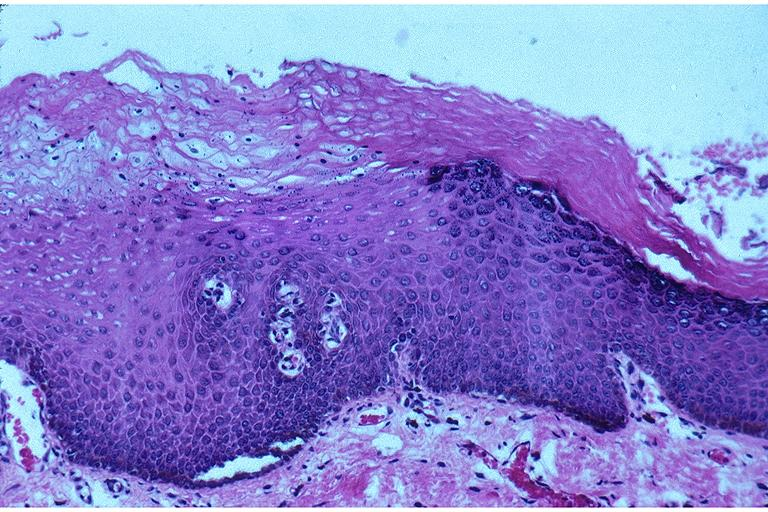does malignant lymphoma large cell type show epithelial hyperplasia and hyperkeratosis?
Answer the question using a single word or phrase. No 